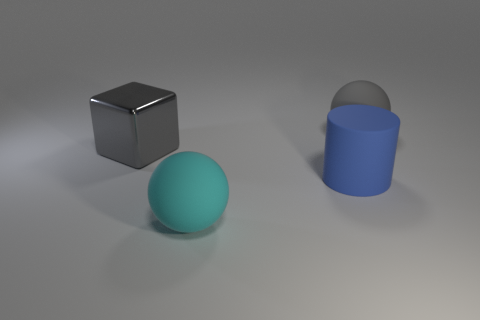Add 3 small purple things. How many objects exist? 7 Subtract all blocks. How many objects are left? 3 Add 1 green matte cubes. How many green matte cubes exist? 1 Subtract 0 red blocks. How many objects are left? 4 Subtract all gray rubber objects. Subtract all large shiny cubes. How many objects are left? 2 Add 3 cyan objects. How many cyan objects are left? 4 